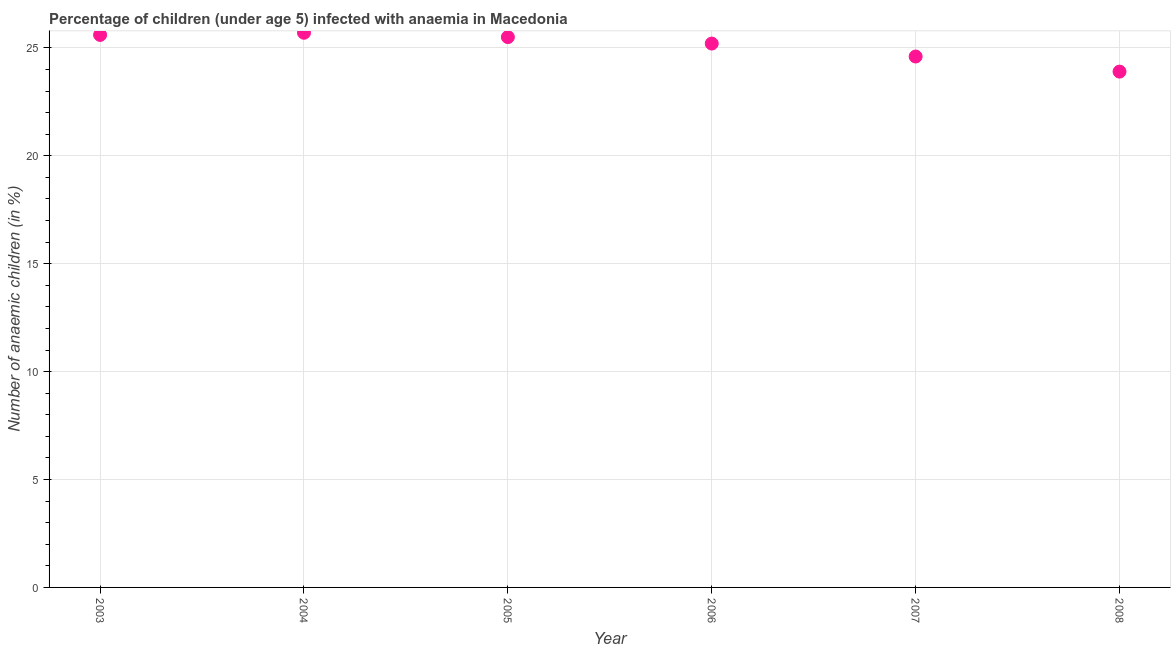What is the number of anaemic children in 2008?
Make the answer very short. 23.9. Across all years, what is the maximum number of anaemic children?
Ensure brevity in your answer.  25.7. Across all years, what is the minimum number of anaemic children?
Your response must be concise. 23.9. In which year was the number of anaemic children minimum?
Your answer should be compact. 2008. What is the sum of the number of anaemic children?
Ensure brevity in your answer.  150.5. What is the difference between the number of anaemic children in 2005 and 2008?
Your response must be concise. 1.6. What is the average number of anaemic children per year?
Offer a very short reply. 25.08. What is the median number of anaemic children?
Your answer should be very brief. 25.35. Do a majority of the years between 2007 and 2008 (inclusive) have number of anaemic children greater than 2 %?
Provide a succinct answer. Yes. What is the ratio of the number of anaemic children in 2006 to that in 2007?
Your response must be concise. 1.02. What is the difference between the highest and the second highest number of anaemic children?
Ensure brevity in your answer.  0.1. What is the difference between the highest and the lowest number of anaemic children?
Provide a short and direct response. 1.8. In how many years, is the number of anaemic children greater than the average number of anaemic children taken over all years?
Give a very brief answer. 4. Does the number of anaemic children monotonically increase over the years?
Ensure brevity in your answer.  No. How many dotlines are there?
Your answer should be compact. 1. How many years are there in the graph?
Ensure brevity in your answer.  6. Does the graph contain any zero values?
Your answer should be very brief. No. Does the graph contain grids?
Your answer should be very brief. Yes. What is the title of the graph?
Make the answer very short. Percentage of children (under age 5) infected with anaemia in Macedonia. What is the label or title of the Y-axis?
Provide a succinct answer. Number of anaemic children (in %). What is the Number of anaemic children (in %) in 2003?
Provide a succinct answer. 25.6. What is the Number of anaemic children (in %) in 2004?
Your answer should be very brief. 25.7. What is the Number of anaemic children (in %) in 2005?
Offer a terse response. 25.5. What is the Number of anaemic children (in %) in 2006?
Provide a succinct answer. 25.2. What is the Number of anaemic children (in %) in 2007?
Your answer should be compact. 24.6. What is the Number of anaemic children (in %) in 2008?
Offer a very short reply. 23.9. What is the difference between the Number of anaemic children (in %) in 2004 and 2006?
Provide a short and direct response. 0.5. What is the difference between the Number of anaemic children (in %) in 2004 and 2007?
Your answer should be very brief. 1.1. What is the difference between the Number of anaemic children (in %) in 2004 and 2008?
Give a very brief answer. 1.8. What is the difference between the Number of anaemic children (in %) in 2005 and 2007?
Your answer should be compact. 0.9. What is the difference between the Number of anaemic children (in %) in 2006 and 2007?
Your answer should be very brief. 0.6. What is the ratio of the Number of anaemic children (in %) in 2003 to that in 2004?
Provide a short and direct response. 1. What is the ratio of the Number of anaemic children (in %) in 2003 to that in 2007?
Offer a terse response. 1.04. What is the ratio of the Number of anaemic children (in %) in 2003 to that in 2008?
Provide a succinct answer. 1.07. What is the ratio of the Number of anaemic children (in %) in 2004 to that in 2005?
Your answer should be compact. 1.01. What is the ratio of the Number of anaemic children (in %) in 2004 to that in 2007?
Keep it short and to the point. 1.04. What is the ratio of the Number of anaemic children (in %) in 2004 to that in 2008?
Offer a terse response. 1.07. What is the ratio of the Number of anaemic children (in %) in 2005 to that in 2007?
Keep it short and to the point. 1.04. What is the ratio of the Number of anaemic children (in %) in 2005 to that in 2008?
Ensure brevity in your answer.  1.07. What is the ratio of the Number of anaemic children (in %) in 2006 to that in 2008?
Provide a succinct answer. 1.05. What is the ratio of the Number of anaemic children (in %) in 2007 to that in 2008?
Provide a succinct answer. 1.03. 